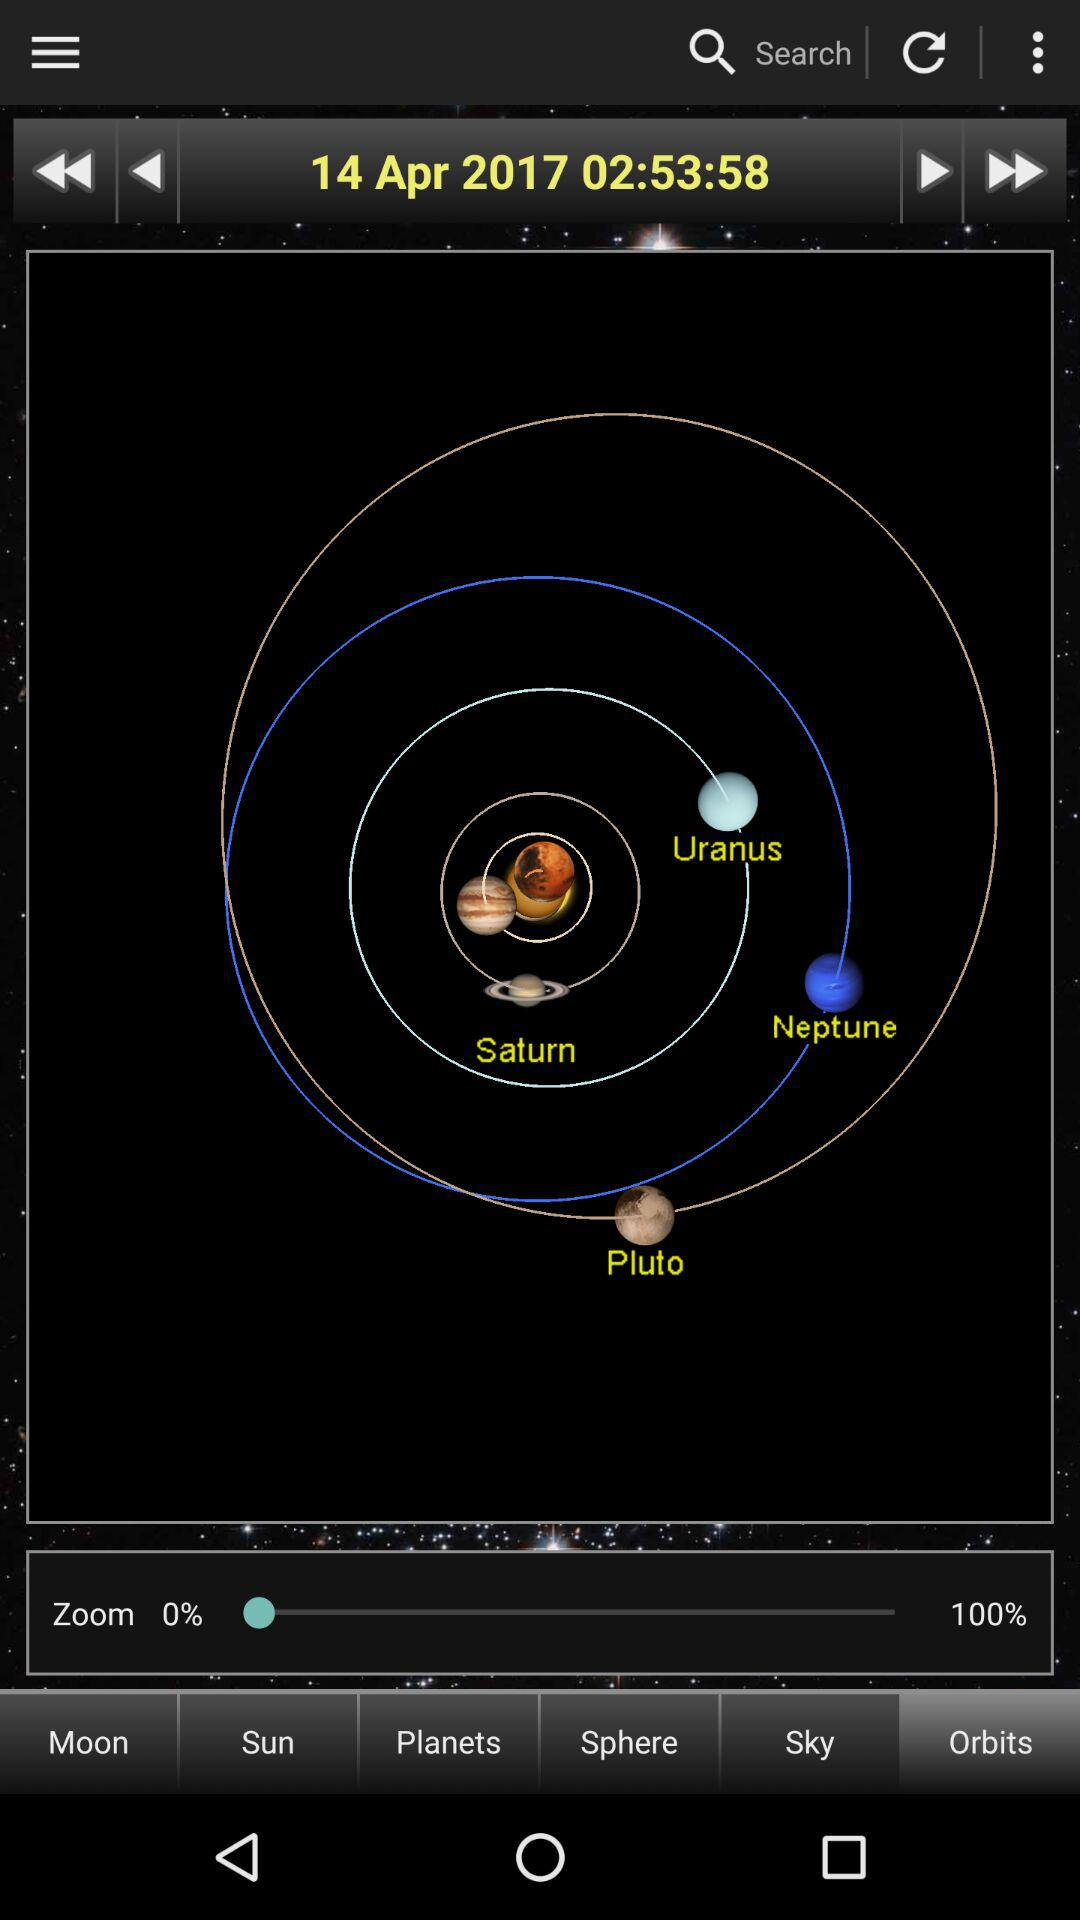What is the selected tab? The selected tab is "Orbits". 